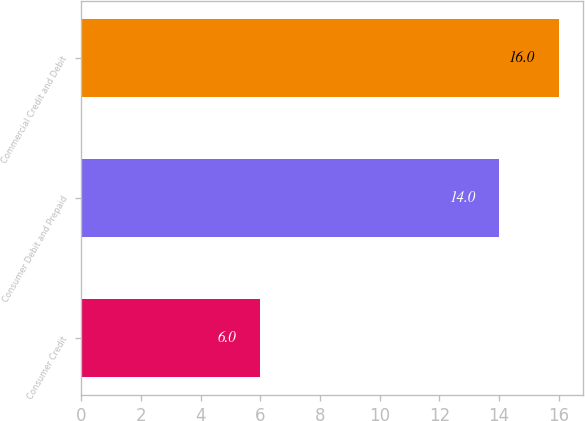Convert chart. <chart><loc_0><loc_0><loc_500><loc_500><bar_chart><fcel>Consumer Credit<fcel>Consumer Debit and Prepaid<fcel>Commercial Credit and Debit<nl><fcel>6<fcel>14<fcel>16<nl></chart> 